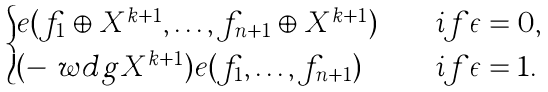Convert formula to latex. <formula><loc_0><loc_0><loc_500><loc_500>\begin{cases} e ( f _ { 1 } \oplus X ^ { k + 1 } , \dots , f _ { n + 1 } \oplus X ^ { k + 1 } ) \quad & i f \epsilon = 0 , \\ ( - \ w d g X ^ { k + 1 } ) e ( f _ { 1 } , \dots , f _ { n + 1 } ) \quad & i f \epsilon = 1 . \end{cases}</formula> 